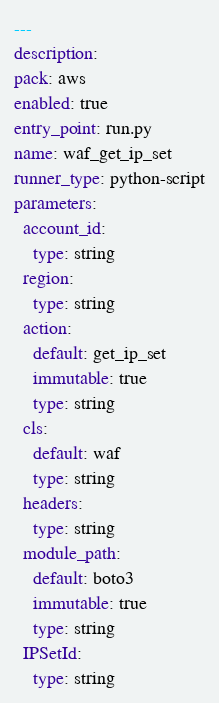Convert code to text. <code><loc_0><loc_0><loc_500><loc_500><_YAML_>---
description: 
pack: aws
enabled: true
entry_point: run.py
name: waf_get_ip_set
runner_type: python-script
parameters:
  account_id:
    type: string
  region:
    type: string
  action:
    default: get_ip_set
    immutable: true
    type: string
  cls:
    default: waf
    type: string
  headers:
    type: string
  module_path:
    default: boto3
    immutable: true
    type: string
  IPSetId:
    type: string</code> 